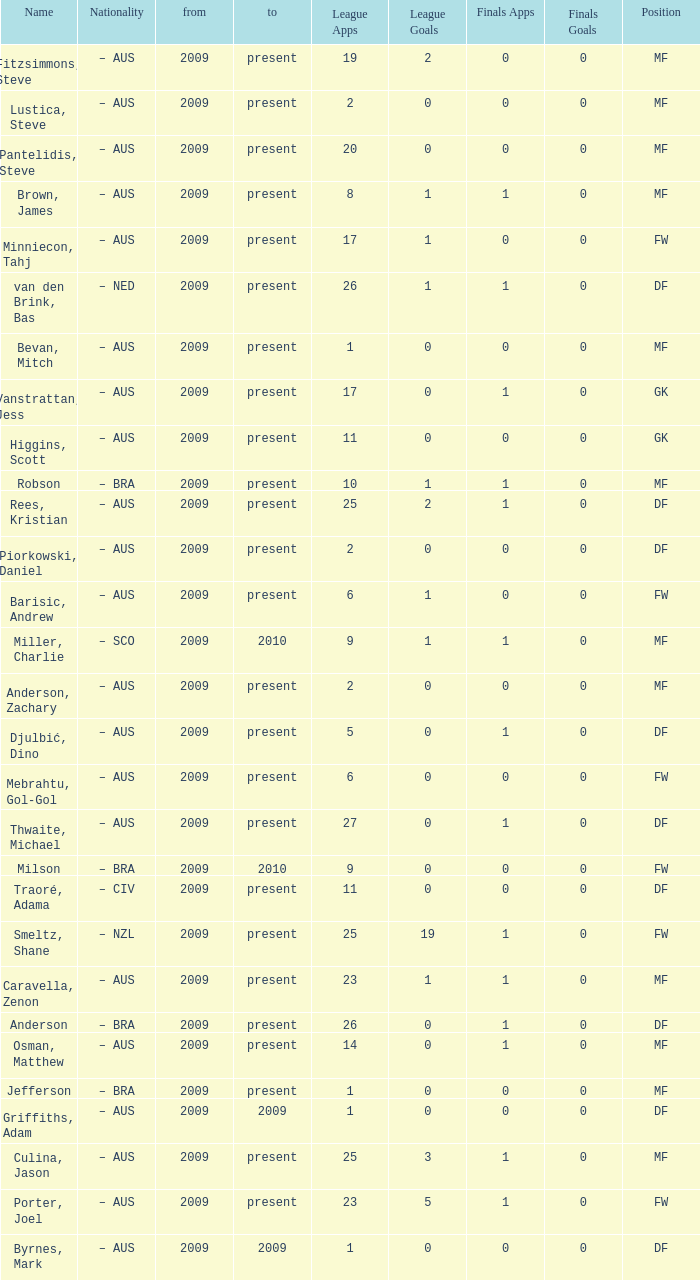Name the mosst finals apps 1.0. 